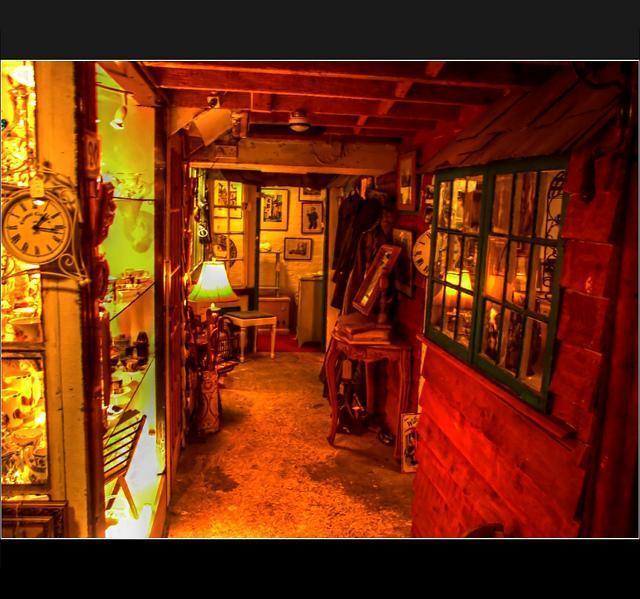How many people have glasses on their sitting on their heads?
Give a very brief answer. 0. 